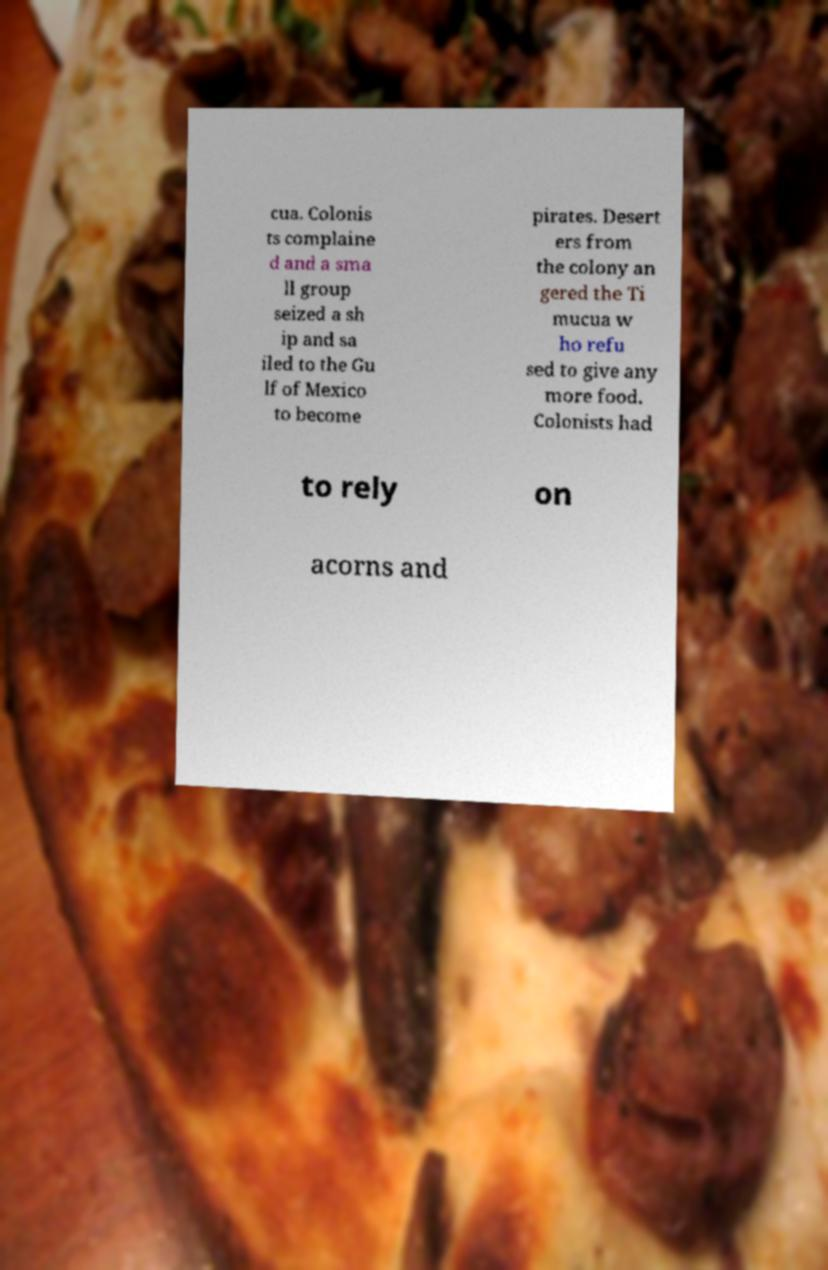There's text embedded in this image that I need extracted. Can you transcribe it verbatim? cua. Colonis ts complaine d and a sma ll group seized a sh ip and sa iled to the Gu lf of Mexico to become pirates. Desert ers from the colony an gered the Ti mucua w ho refu sed to give any more food. Colonists had to rely on acorns and 